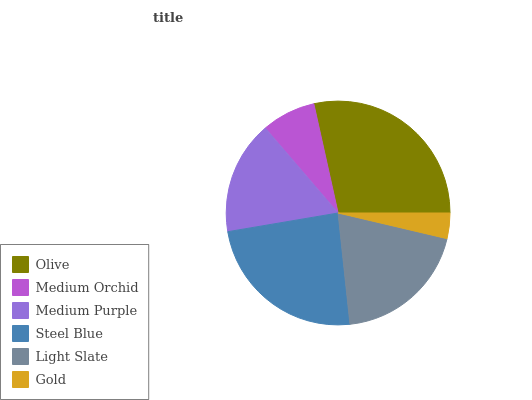Is Gold the minimum?
Answer yes or no. Yes. Is Olive the maximum?
Answer yes or no. Yes. Is Medium Orchid the minimum?
Answer yes or no. No. Is Medium Orchid the maximum?
Answer yes or no. No. Is Olive greater than Medium Orchid?
Answer yes or no. Yes. Is Medium Orchid less than Olive?
Answer yes or no. Yes. Is Medium Orchid greater than Olive?
Answer yes or no. No. Is Olive less than Medium Orchid?
Answer yes or no. No. Is Light Slate the high median?
Answer yes or no. Yes. Is Medium Purple the low median?
Answer yes or no. Yes. Is Medium Orchid the high median?
Answer yes or no. No. Is Medium Orchid the low median?
Answer yes or no. No. 